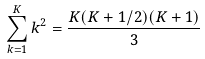Convert formula to latex. <formula><loc_0><loc_0><loc_500><loc_500>\sum _ { k = 1 } ^ { K } k ^ { 2 } = \frac { K ( K + 1 / 2 ) ( K + 1 ) } { 3 }</formula> 